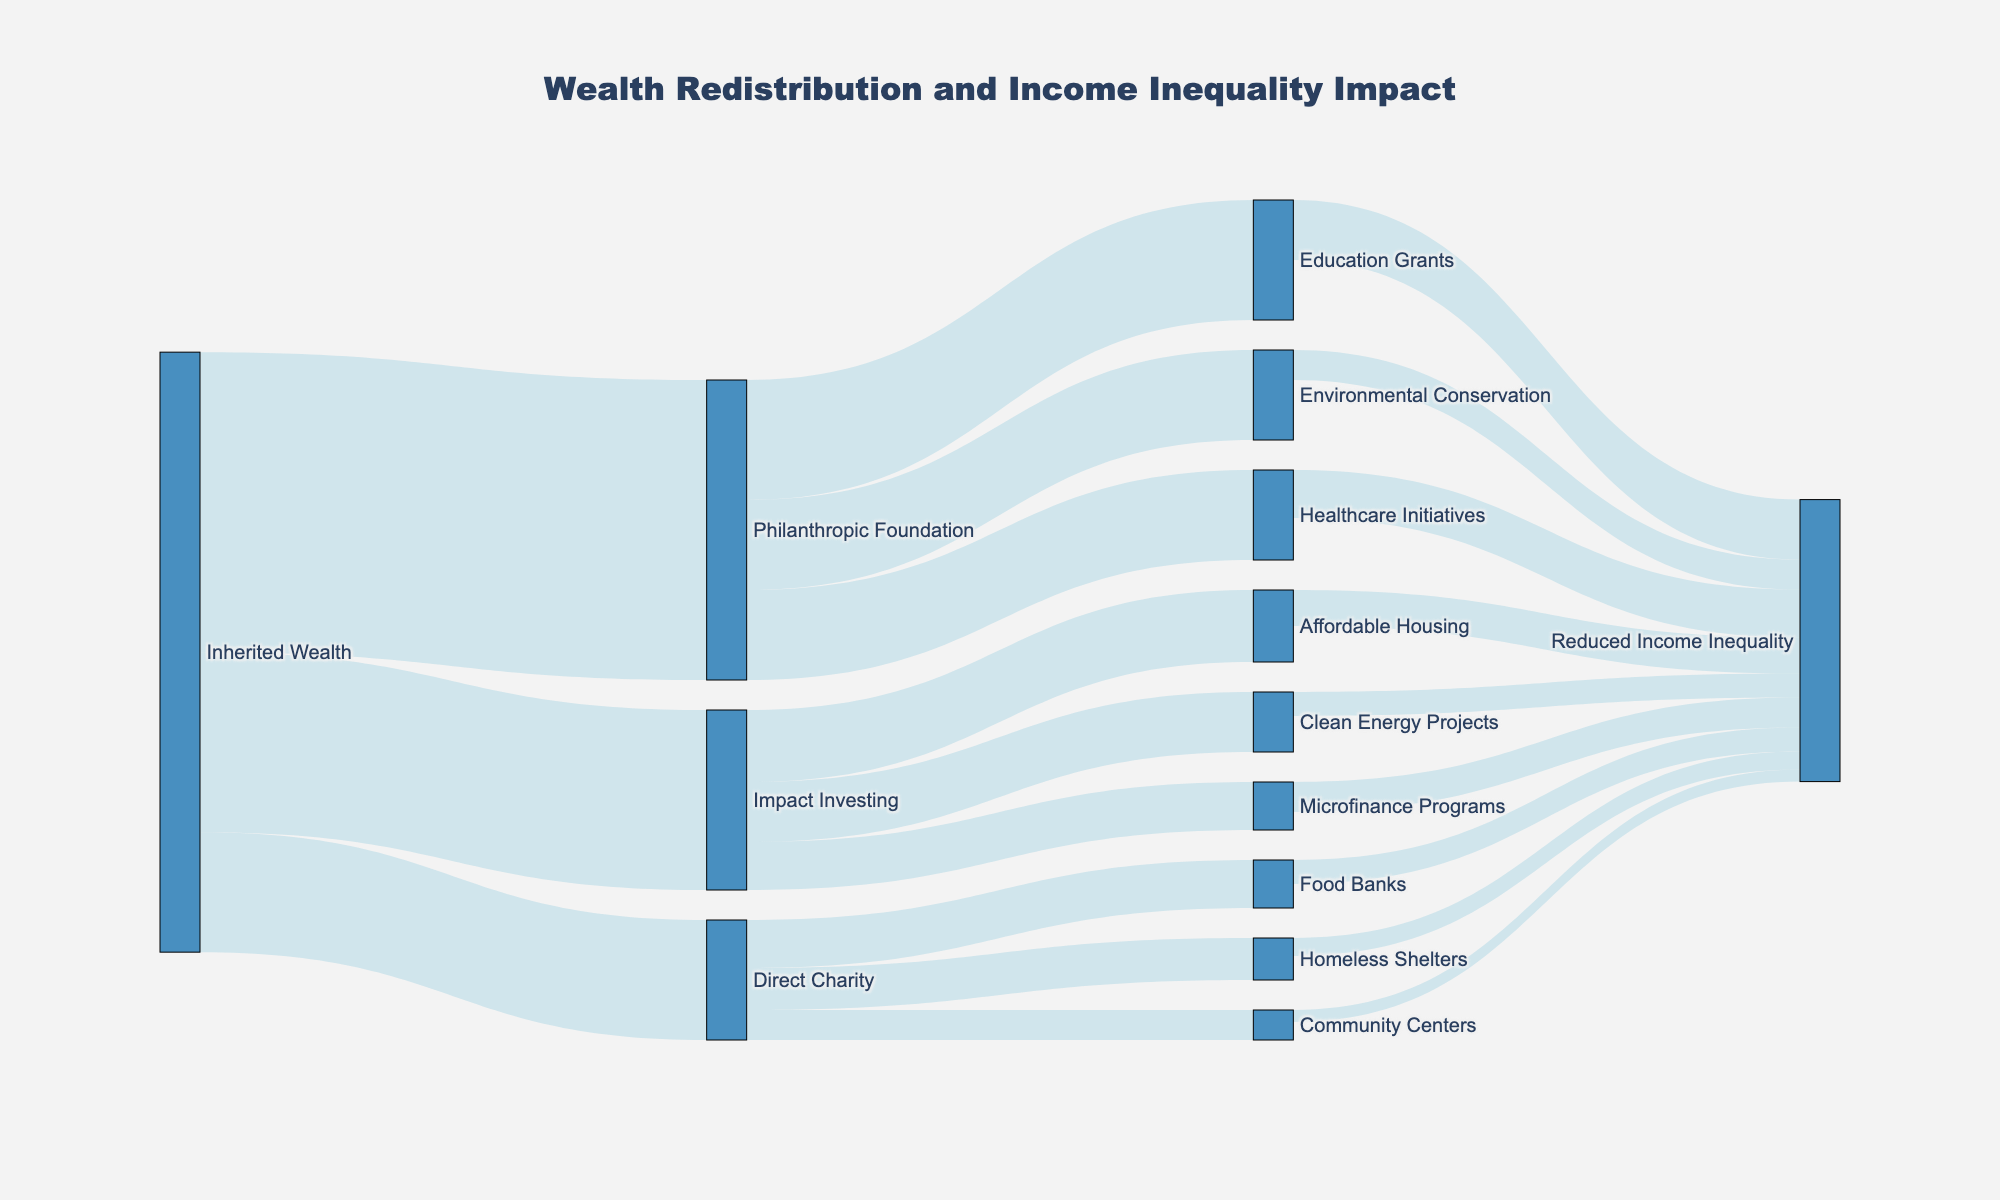what is the title of the figure? The title of the figure is displayed at the top of the Sankey diagram. It states, "Wealth Redistribution and Income Inequality Impact."
Answer: Wealth Redistribution and Income Inequality Impact What are the three main redistribution methods shown in the figure? The three main redistribution methods can be identified by looking at the primary nodes that stem directly from "Inherited Wealth." These nodes are "Philanthropic Foundation," "Impact Investing," and "Direct Charity."
Answer: Philanthropic Foundation, Impact Investing, Direct Charity How much wealth is directed towards “Healthcare Initiatives”? From the node "Philanthropic Foundation," there is a flow directed towards "Healthcare Initiatives." The value of this flow is labeled as 15 in the figure.
Answer: 15 Which redistribution method received the highest amount of inherited wealth? By observing the values flowing from "Inherited Wealth," it's evident that “Philanthropic Foundation” received the highest amount, which is labeled 50.
Answer: Philanthropic Foundation How much wealth flows from “Impact Investing” to “Clean Energy Projects” and "Microfinance Programs" combined? The value of the flow from “Impact Investing” to “Clean Energy Projects” is 10, and to “Microfinance Programs” is 8. Adding these values together gives 10 + 8 = 18.
Answer: 18 What is the total amount of wealth that results in “Reduced Income Inequality”? Sum the values flowing to “Reduced Income Inequality” from different initiatives: Education Grants (10), Healthcare Initiatives (8), Environmental Conservation (5), Affordable Housing (6), Clean Energy Projects (4), Microfinance Programs (5), Food Banks (4), Homeless Shelters (3), and Community Centers (2). Thus, 10+8+5+6+4+5+4+3+2 = 47.
Answer: 47 Which initiative under “Direct Charity” has the least impact on reducing income inequality? Under “Direct Charity,” the flows to “Reduced Income Inequality” show values for Food Banks (4), Homeless Shelters (3), and Community Centers (2). The smallest value among these is for "Community Centers," which is 2.
Answer: Community Centers Compare the wealth distributed to “Education Grants” and “Microfinance Programs.” Which one receives more, and by how much? The flow from “Philanthropic Foundation” to “Education Grants” is 20, and the flow from “Impact Investing” to “Microfinance Programs” is 8. The difference is 20 - 8 = 12, indicating that “Education Grants” receives more.
Answer: Education Grants, 12 What percentage of the total inherited wealth is directed to “Direct Charity”? The total inherited wealth is 50 (Philanthropic Foundation) + 30 (Impact Investing) + 20 (Direct Charity) = 100. The wealth directed to "Direct Charity" is 20. The percentage is (20/100) * 100 = 20%.
Answer: 20% Which initiative specifically under “Philanthropic Foundation” contributes the least to reducing income inequality? From the nodes under “Philanthropic Foundation,” the contributions to “Reduced Income Inequality” are measured for Education Grants (10), Healthcare Initiatives (8), and Environmental Conservation (5). The smallest value is for "Environmental Conservation," with a value of 5.
Answer: Environmental Conservation 